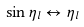Convert formula to latex. <formula><loc_0><loc_0><loc_500><loc_500>\sin \eta _ { l } \leftrightarrow \eta _ { l }</formula> 